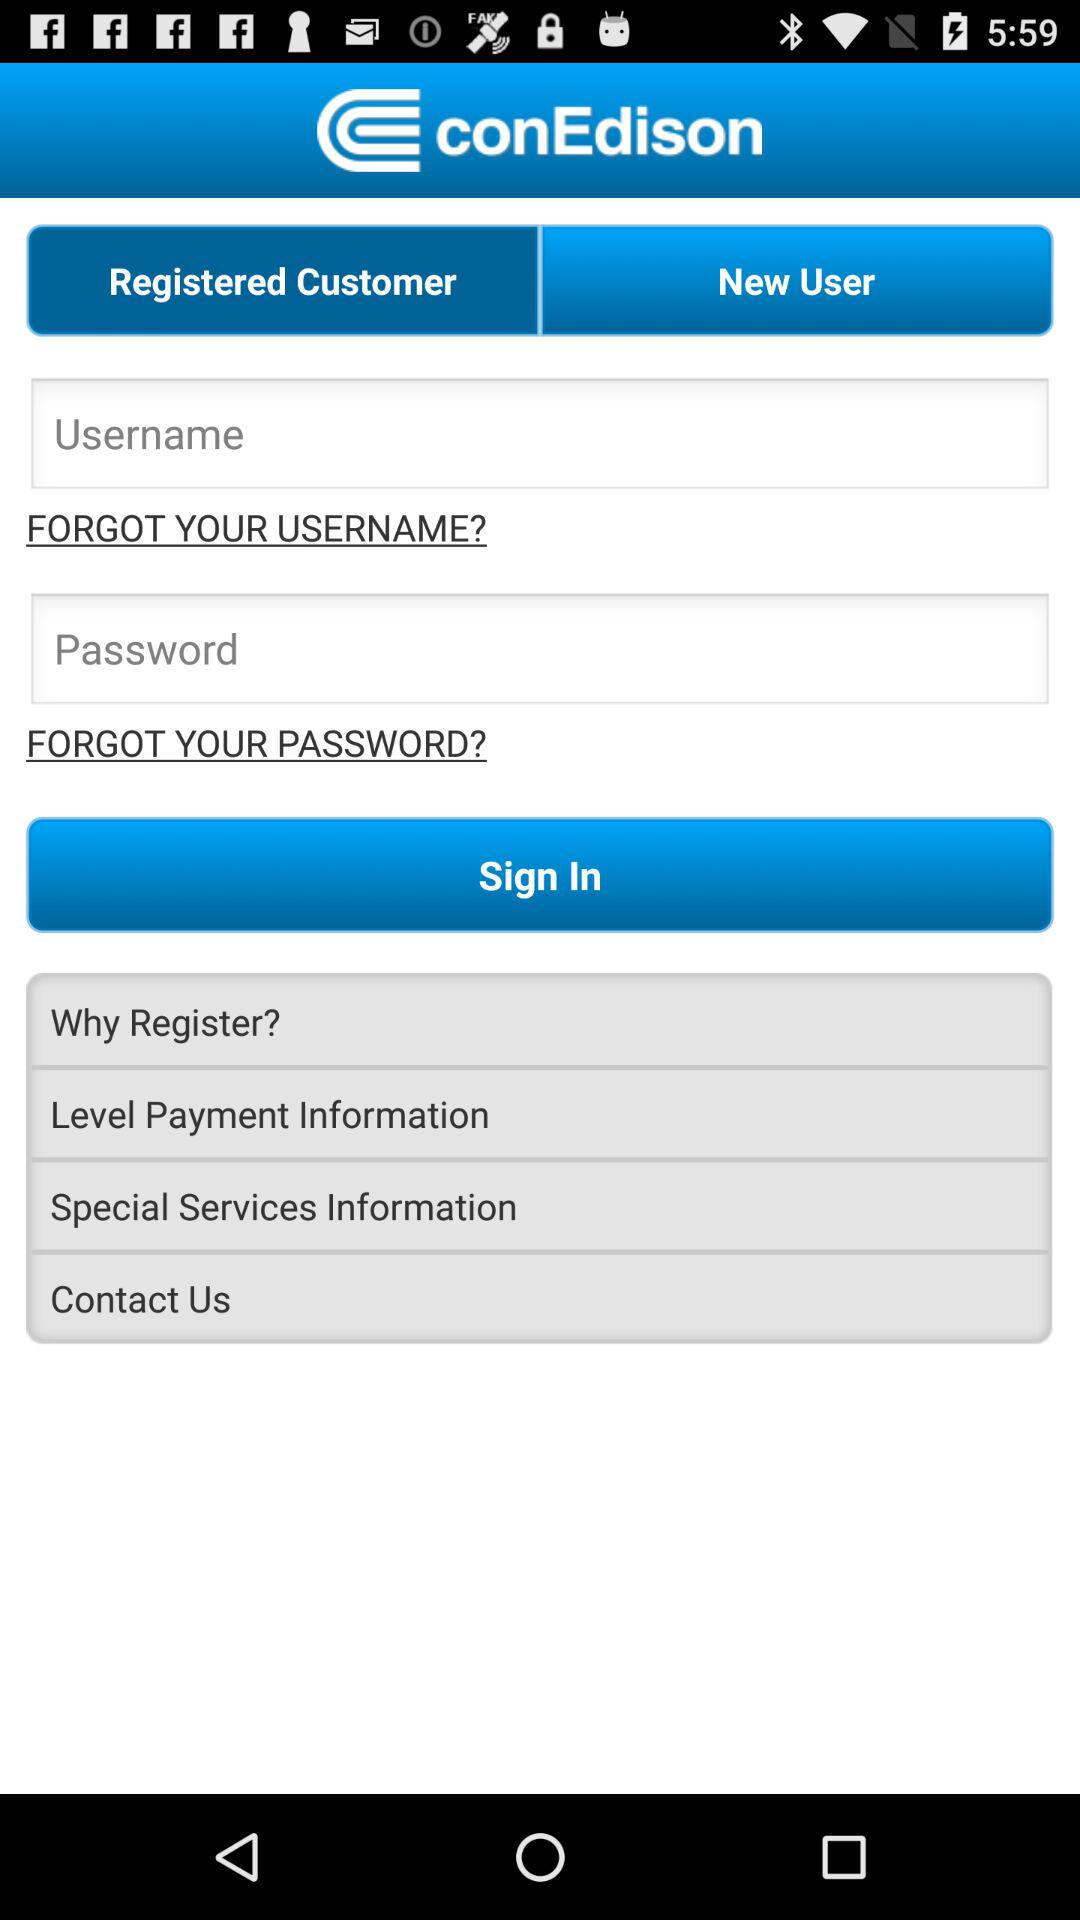What is the name of the application? The name of the application is "conEdison". 